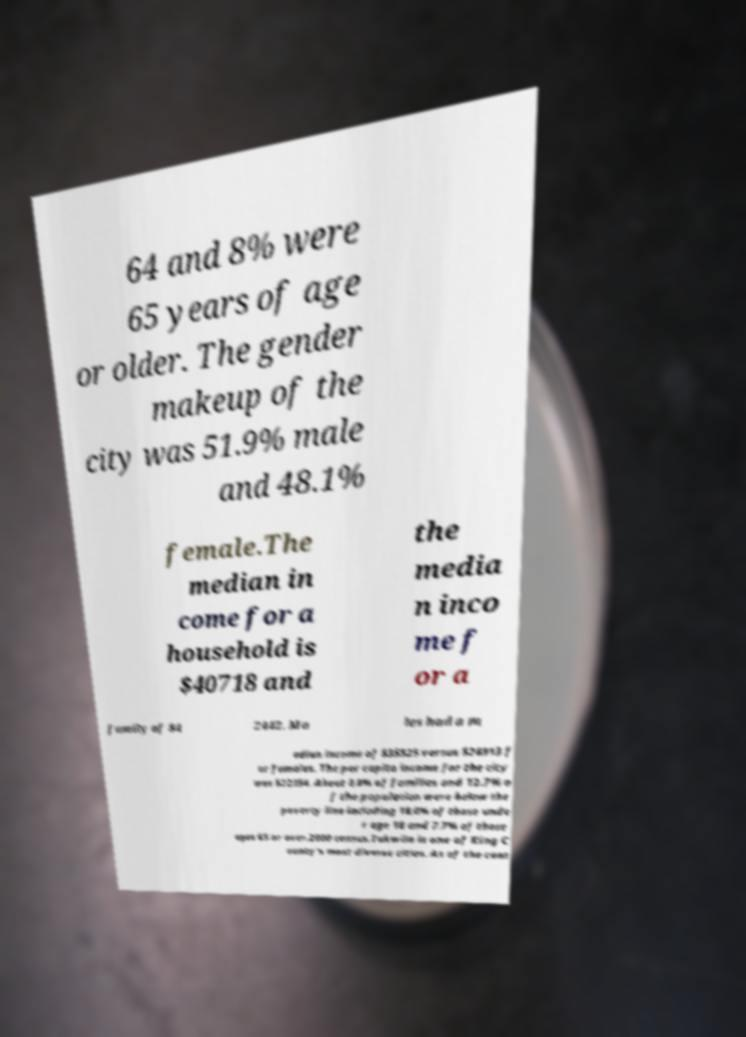For documentation purposes, I need the text within this image transcribed. Could you provide that? 64 and 8% were 65 years of age or older. The gender makeup of the city was 51.9% male and 48.1% female.The median in come for a household is $40718 and the media n inco me f or a family of $4 2442. Ma les had a m edian income of $35525 versus $28913 f or females. The per capita income for the city was $22354. About 8.8% of families and 12.7% o f the population were below the poverty line including 18.0% of those unde r age 18 and 7.7% of those ages 65 or over.2000 census.Tukwila is one of King C ounty's most diverse cities. As of the cens 